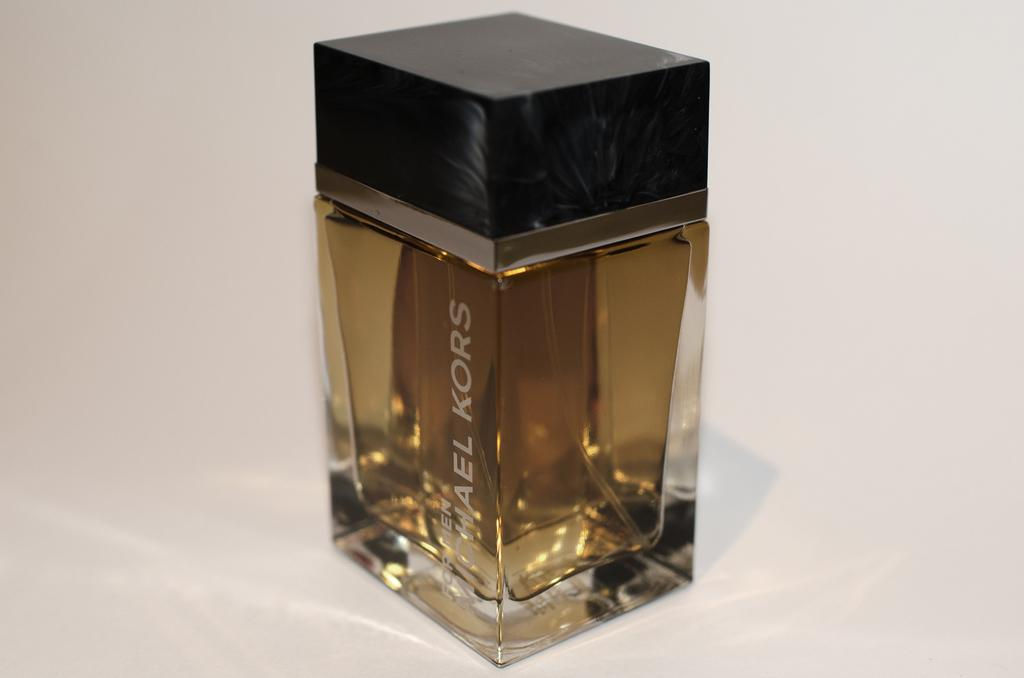<image>
Create a compact narrative representing the image presented. A small glass bottle by Michael Kors sits on a white surface. 